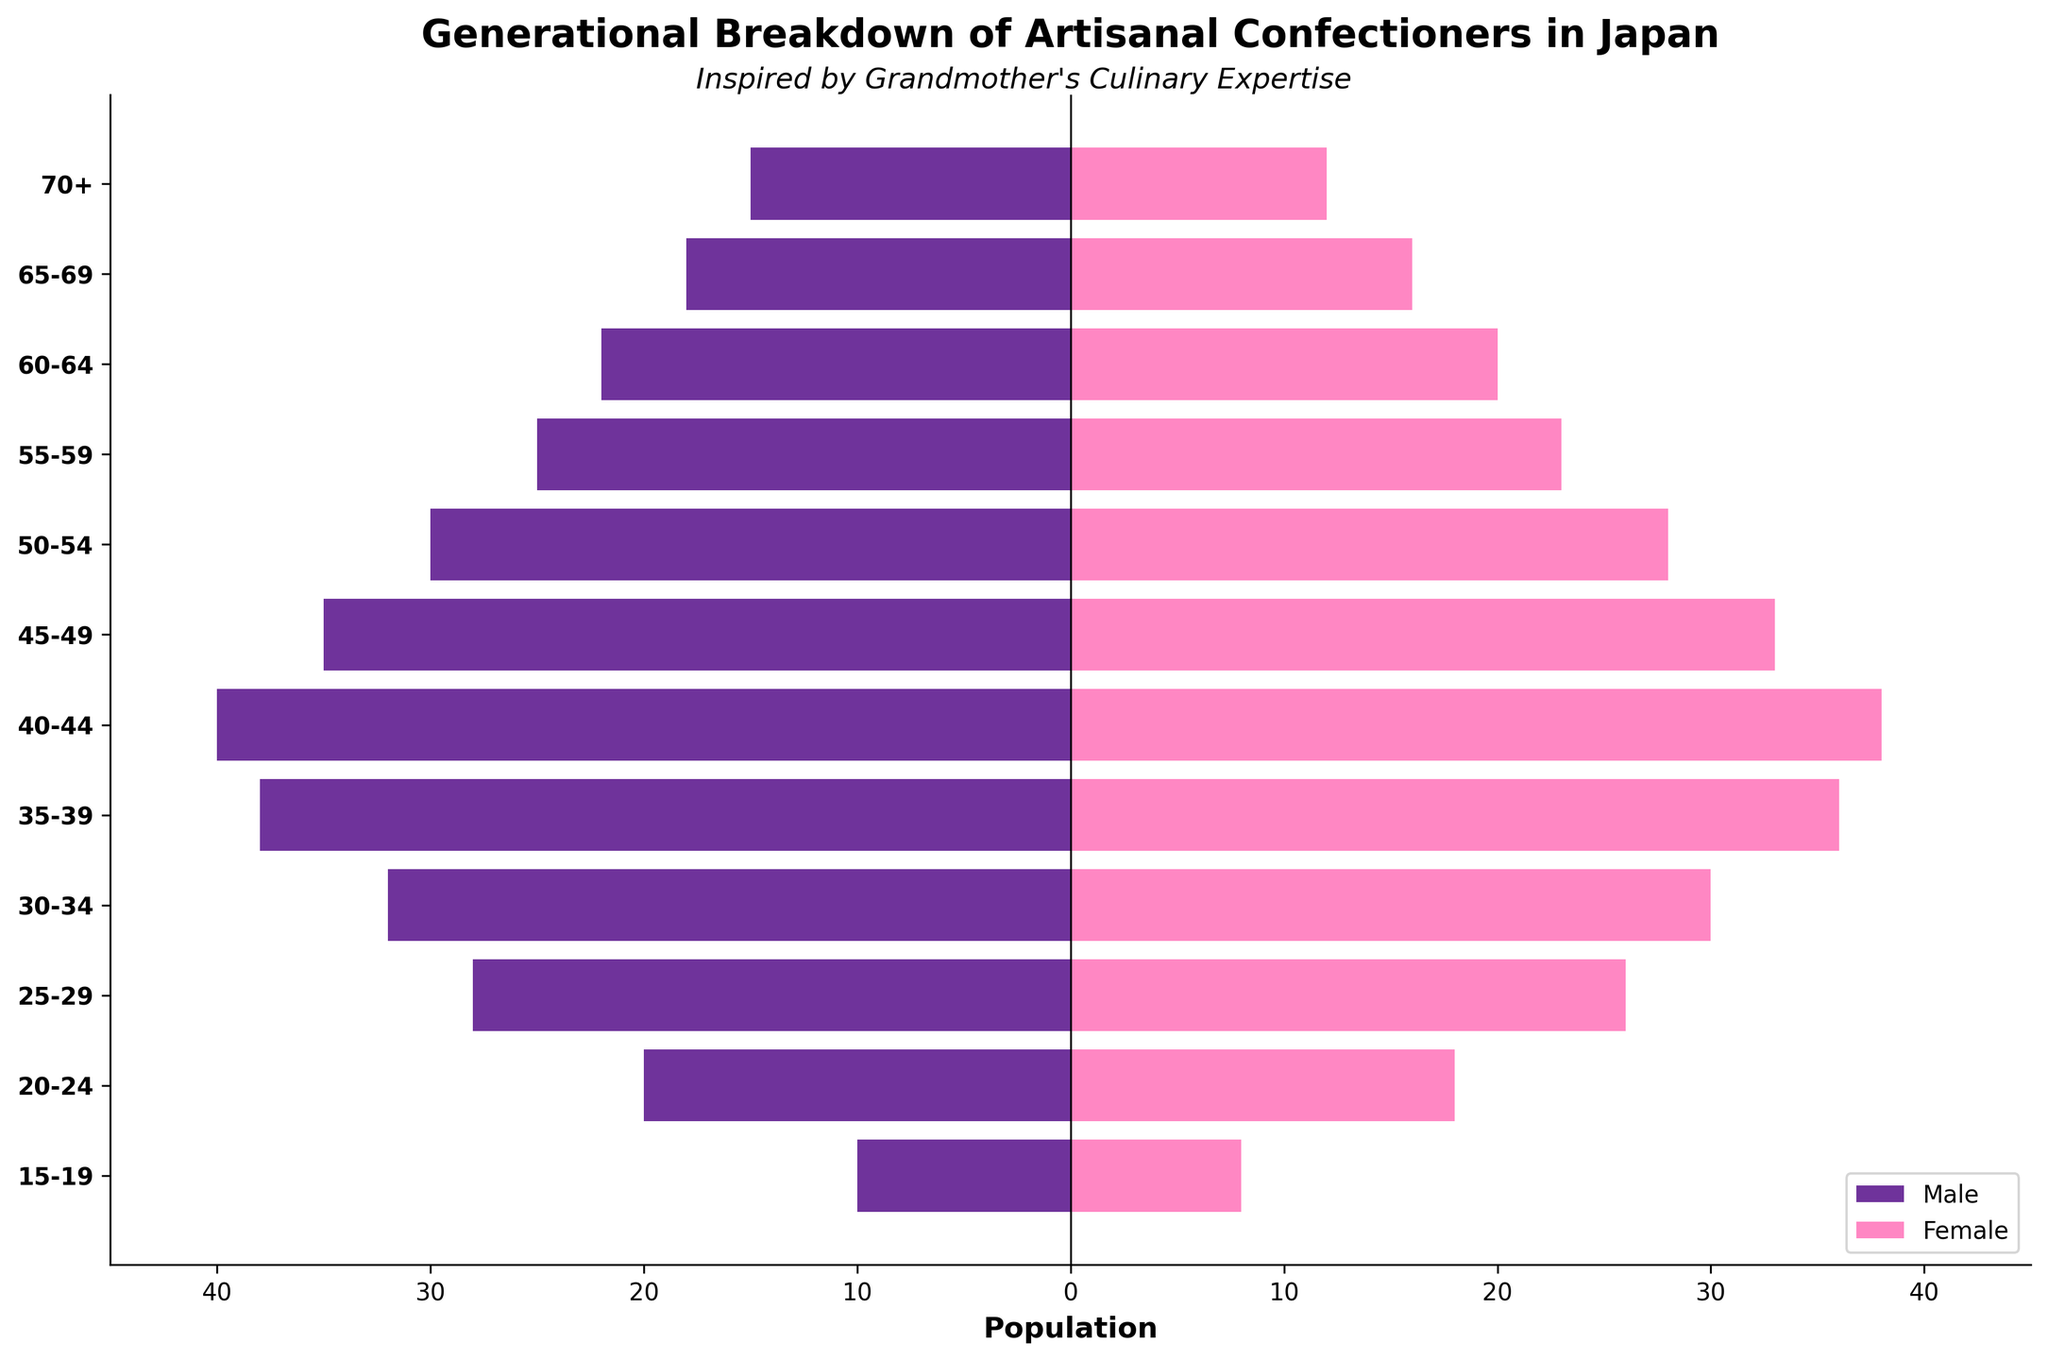What is the title of the plot? The title is usually displayed at the top of the figure. For this plot, the title is written in bold and mentions the focus of the study.
Answer: Generational Breakdown of Artisanal Confectioners in Japan Which gender has more artisanal confectioners in the 25-29 age group? By comparing the length of the bars for the male and female values in this age group, the male bar extends further left than the female bar extends right.
Answer: Male How many female artisanal confectioners are there in the 15-19 and 20-24 age groups combined? Identify the specific values for the female confectioners in the 15-19 (8) and 20-24 (18) age groups. Add these values together: 8 + 18.
Answer: 26 Which age group has the difference in the number of male and female confectioners equal to 2? Calculate the difference between male and female values for each age group and find the one with a difference of 2. The 70+ age group has 15 males and 12 females, and 15 - 12 equals 3, which is the closest to 2.
Answer: None In which age group is the population of male confectioners the highest? Check the bar lengths for male confectioners across all age groups. The age group with the longest negative bar represents the highest population.
Answer: 40-44 What is the total number of male and female confectioners in the 60-64 age group? Add the values of male (22) and female (20) confectioners in the 60-64 age group: 22 + 20.
Answer: 42 What percentage of the total confectioners aged 50-54 are female? Calculate the total confectioners (30 male + 28 female = 58) and then determine the percentage that is female: (28/58) * 100.
Answer: 48.3% Which age group has the lowest number of confectioners regardless of gender? Compare the sums of male and female values for each age group and identify the lowest. The 15-19 age group has 10 males and 8 females, totalling 18.
Answer: 15-19 How does the number of female confectioners aged 45-49 compare to those aged 30-34? Directly compare the values of female confectioners in these age groups: 45-49 has 33 females, and 30-34 has 30 females.
Answer: Higher in 45-49 What is the trend in the number of male confectioners as age decreases from 70+ to 40-44? Observing the bars for male confectioners from 70+ down to 40-44, the number of males increases as the age group gets younger, peaking at 40-44.
Answer: Increasing 